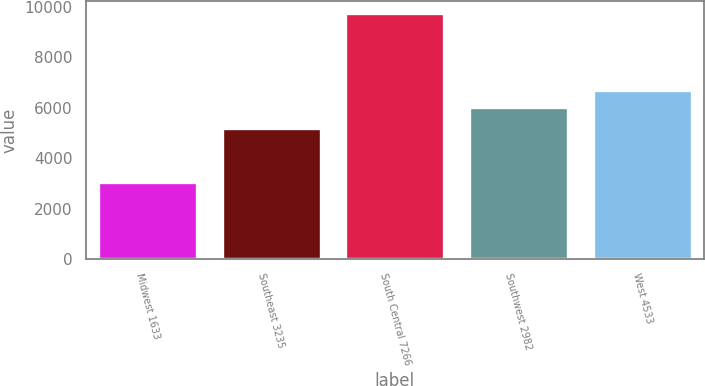<chart> <loc_0><loc_0><loc_500><loc_500><bar_chart><fcel>Midwest 1633<fcel>Southeast 3235<fcel>South Central 7266<fcel>Southwest 2982<fcel>West 4533<nl><fcel>3065<fcel>5206<fcel>9740<fcel>6017<fcel>6684.5<nl></chart> 